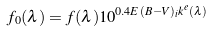Convert formula to latex. <formula><loc_0><loc_0><loc_500><loc_500>f _ { 0 } ( \lambda ) = f ( \lambda ) 1 0 ^ { 0 . 4 E ( B - V ) _ { i } k ^ { e } ( \lambda ) }</formula> 